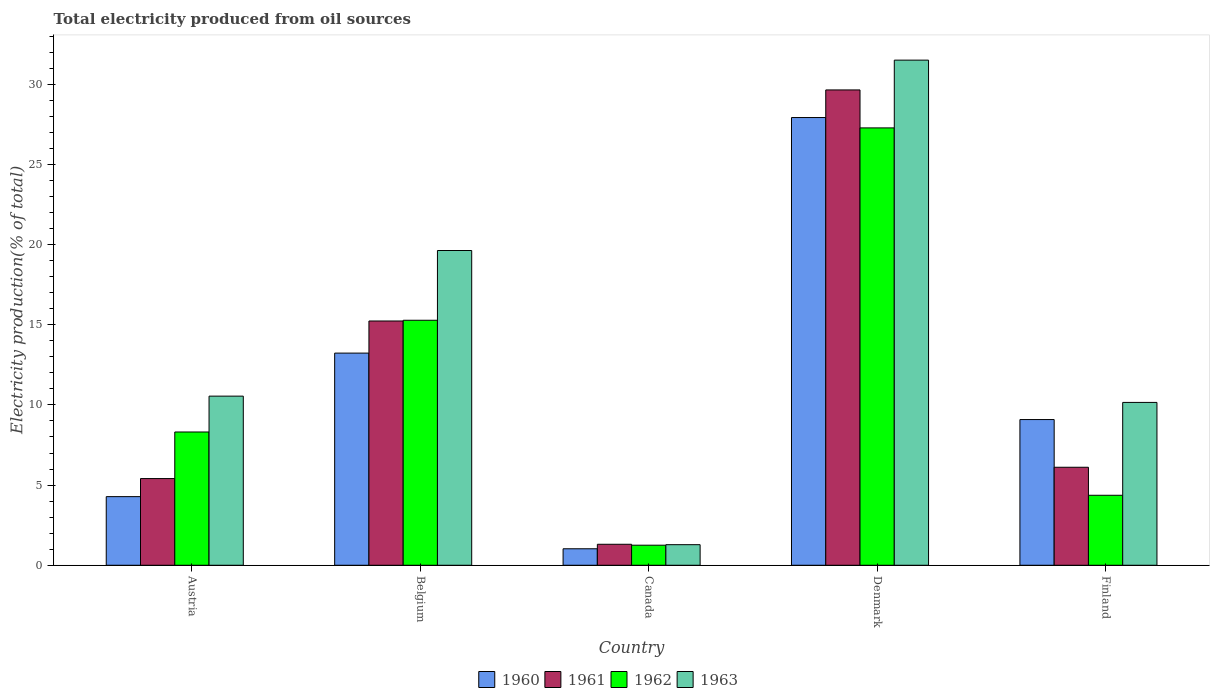How many groups of bars are there?
Offer a very short reply. 5. Are the number of bars per tick equal to the number of legend labels?
Ensure brevity in your answer.  Yes. How many bars are there on the 4th tick from the right?
Your answer should be compact. 4. What is the label of the 4th group of bars from the left?
Ensure brevity in your answer.  Denmark. In how many cases, is the number of bars for a given country not equal to the number of legend labels?
Your response must be concise. 0. What is the total electricity produced in 1963 in Denmark?
Your answer should be very brief. 31.51. Across all countries, what is the maximum total electricity produced in 1960?
Your answer should be compact. 27.92. Across all countries, what is the minimum total electricity produced in 1962?
Offer a terse response. 1.25. In which country was the total electricity produced in 1962 minimum?
Offer a terse response. Canada. What is the total total electricity produced in 1961 in the graph?
Provide a succinct answer. 57.71. What is the difference between the total electricity produced in 1960 in Canada and that in Finland?
Your response must be concise. -8.06. What is the difference between the total electricity produced in 1962 in Austria and the total electricity produced in 1960 in Canada?
Your answer should be compact. 7.28. What is the average total electricity produced in 1962 per country?
Keep it short and to the point. 11.3. What is the difference between the total electricity produced of/in 1962 and total electricity produced of/in 1960 in Canada?
Provide a short and direct response. 0.22. In how many countries, is the total electricity produced in 1962 greater than 16 %?
Make the answer very short. 1. What is the ratio of the total electricity produced in 1962 in Austria to that in Denmark?
Provide a succinct answer. 0.3. Is the total electricity produced in 1961 in Belgium less than that in Canada?
Ensure brevity in your answer.  No. Is the difference between the total electricity produced in 1962 in Austria and Denmark greater than the difference between the total electricity produced in 1960 in Austria and Denmark?
Offer a terse response. Yes. What is the difference between the highest and the second highest total electricity produced in 1961?
Your response must be concise. 23.53. What is the difference between the highest and the lowest total electricity produced in 1963?
Provide a short and direct response. 30.22. Is the sum of the total electricity produced in 1960 in Canada and Denmark greater than the maximum total electricity produced in 1962 across all countries?
Offer a terse response. Yes. What does the 1st bar from the right in Belgium represents?
Offer a terse response. 1963. Is it the case that in every country, the sum of the total electricity produced in 1960 and total electricity produced in 1961 is greater than the total electricity produced in 1963?
Give a very brief answer. No. Are all the bars in the graph horizontal?
Give a very brief answer. No. What is the difference between two consecutive major ticks on the Y-axis?
Ensure brevity in your answer.  5. Are the values on the major ticks of Y-axis written in scientific E-notation?
Provide a succinct answer. No. Does the graph contain any zero values?
Ensure brevity in your answer.  No. Does the graph contain grids?
Your response must be concise. No. How many legend labels are there?
Give a very brief answer. 4. What is the title of the graph?
Your response must be concise. Total electricity produced from oil sources. Does "1986" appear as one of the legend labels in the graph?
Offer a very short reply. No. What is the label or title of the X-axis?
Give a very brief answer. Country. What is the Electricity production(% of total) in 1960 in Austria?
Your response must be concise. 4.28. What is the Electricity production(% of total) in 1961 in Austria?
Ensure brevity in your answer.  5.41. What is the Electricity production(% of total) in 1962 in Austria?
Make the answer very short. 8.31. What is the Electricity production(% of total) in 1963 in Austria?
Offer a terse response. 10.55. What is the Electricity production(% of total) of 1960 in Belgium?
Ensure brevity in your answer.  13.23. What is the Electricity production(% of total) in 1961 in Belgium?
Your response must be concise. 15.23. What is the Electricity production(% of total) of 1962 in Belgium?
Offer a very short reply. 15.28. What is the Electricity production(% of total) of 1963 in Belgium?
Give a very brief answer. 19.63. What is the Electricity production(% of total) of 1960 in Canada?
Provide a succinct answer. 1.03. What is the Electricity production(% of total) in 1961 in Canada?
Keep it short and to the point. 1.31. What is the Electricity production(% of total) of 1962 in Canada?
Keep it short and to the point. 1.25. What is the Electricity production(% of total) of 1963 in Canada?
Make the answer very short. 1.28. What is the Electricity production(% of total) in 1960 in Denmark?
Make the answer very short. 27.92. What is the Electricity production(% of total) of 1961 in Denmark?
Provide a succinct answer. 29.65. What is the Electricity production(% of total) of 1962 in Denmark?
Your response must be concise. 27.28. What is the Electricity production(% of total) of 1963 in Denmark?
Your response must be concise. 31.51. What is the Electricity production(% of total) in 1960 in Finland?
Ensure brevity in your answer.  9.09. What is the Electricity production(% of total) in 1961 in Finland?
Offer a very short reply. 6.11. What is the Electricity production(% of total) in 1962 in Finland?
Make the answer very short. 4.36. What is the Electricity production(% of total) of 1963 in Finland?
Offer a very short reply. 10.16. Across all countries, what is the maximum Electricity production(% of total) in 1960?
Your response must be concise. 27.92. Across all countries, what is the maximum Electricity production(% of total) of 1961?
Your answer should be very brief. 29.65. Across all countries, what is the maximum Electricity production(% of total) in 1962?
Provide a succinct answer. 27.28. Across all countries, what is the maximum Electricity production(% of total) of 1963?
Ensure brevity in your answer.  31.51. Across all countries, what is the minimum Electricity production(% of total) in 1960?
Provide a succinct answer. 1.03. Across all countries, what is the minimum Electricity production(% of total) in 1961?
Give a very brief answer. 1.31. Across all countries, what is the minimum Electricity production(% of total) of 1962?
Offer a very short reply. 1.25. Across all countries, what is the minimum Electricity production(% of total) of 1963?
Provide a short and direct response. 1.28. What is the total Electricity production(% of total) in 1960 in the graph?
Offer a terse response. 55.55. What is the total Electricity production(% of total) in 1961 in the graph?
Offer a terse response. 57.71. What is the total Electricity production(% of total) of 1962 in the graph?
Provide a succinct answer. 56.49. What is the total Electricity production(% of total) of 1963 in the graph?
Your response must be concise. 73.12. What is the difference between the Electricity production(% of total) of 1960 in Austria and that in Belgium?
Keep it short and to the point. -8.95. What is the difference between the Electricity production(% of total) in 1961 in Austria and that in Belgium?
Your answer should be compact. -9.83. What is the difference between the Electricity production(% of total) in 1962 in Austria and that in Belgium?
Your response must be concise. -6.97. What is the difference between the Electricity production(% of total) in 1963 in Austria and that in Belgium?
Offer a terse response. -9.08. What is the difference between the Electricity production(% of total) in 1960 in Austria and that in Canada?
Provide a succinct answer. 3.25. What is the difference between the Electricity production(% of total) in 1961 in Austria and that in Canada?
Provide a succinct answer. 4.1. What is the difference between the Electricity production(% of total) in 1962 in Austria and that in Canada?
Your answer should be compact. 7.06. What is the difference between the Electricity production(% of total) in 1963 in Austria and that in Canada?
Offer a very short reply. 9.26. What is the difference between the Electricity production(% of total) in 1960 in Austria and that in Denmark?
Offer a terse response. -23.64. What is the difference between the Electricity production(% of total) in 1961 in Austria and that in Denmark?
Your answer should be compact. -24.24. What is the difference between the Electricity production(% of total) of 1962 in Austria and that in Denmark?
Keep it short and to the point. -18.97. What is the difference between the Electricity production(% of total) of 1963 in Austria and that in Denmark?
Provide a succinct answer. -20.96. What is the difference between the Electricity production(% of total) of 1960 in Austria and that in Finland?
Make the answer very short. -4.81. What is the difference between the Electricity production(% of total) of 1961 in Austria and that in Finland?
Your answer should be compact. -0.71. What is the difference between the Electricity production(% of total) of 1962 in Austria and that in Finland?
Offer a very short reply. 3.95. What is the difference between the Electricity production(% of total) in 1963 in Austria and that in Finland?
Your answer should be compact. 0.39. What is the difference between the Electricity production(% of total) in 1960 in Belgium and that in Canada?
Provide a short and direct response. 12.2. What is the difference between the Electricity production(% of total) of 1961 in Belgium and that in Canada?
Your response must be concise. 13.93. What is the difference between the Electricity production(% of total) in 1962 in Belgium and that in Canada?
Ensure brevity in your answer.  14.03. What is the difference between the Electricity production(% of total) in 1963 in Belgium and that in Canada?
Keep it short and to the point. 18.35. What is the difference between the Electricity production(% of total) in 1960 in Belgium and that in Denmark?
Offer a terse response. -14.69. What is the difference between the Electricity production(% of total) of 1961 in Belgium and that in Denmark?
Keep it short and to the point. -14.41. What is the difference between the Electricity production(% of total) of 1962 in Belgium and that in Denmark?
Ensure brevity in your answer.  -12. What is the difference between the Electricity production(% of total) in 1963 in Belgium and that in Denmark?
Offer a terse response. -11.87. What is the difference between the Electricity production(% of total) in 1960 in Belgium and that in Finland?
Offer a very short reply. 4.14. What is the difference between the Electricity production(% of total) of 1961 in Belgium and that in Finland?
Ensure brevity in your answer.  9.12. What is the difference between the Electricity production(% of total) of 1962 in Belgium and that in Finland?
Give a very brief answer. 10.92. What is the difference between the Electricity production(% of total) in 1963 in Belgium and that in Finland?
Your answer should be very brief. 9.47. What is the difference between the Electricity production(% of total) of 1960 in Canada and that in Denmark?
Ensure brevity in your answer.  -26.9. What is the difference between the Electricity production(% of total) in 1961 in Canada and that in Denmark?
Your response must be concise. -28.34. What is the difference between the Electricity production(% of total) of 1962 in Canada and that in Denmark?
Keep it short and to the point. -26.03. What is the difference between the Electricity production(% of total) of 1963 in Canada and that in Denmark?
Your answer should be very brief. -30.22. What is the difference between the Electricity production(% of total) in 1960 in Canada and that in Finland?
Keep it short and to the point. -8.06. What is the difference between the Electricity production(% of total) in 1961 in Canada and that in Finland?
Keep it short and to the point. -4.8. What is the difference between the Electricity production(% of total) in 1962 in Canada and that in Finland?
Your response must be concise. -3.11. What is the difference between the Electricity production(% of total) in 1963 in Canada and that in Finland?
Your response must be concise. -8.87. What is the difference between the Electricity production(% of total) in 1960 in Denmark and that in Finland?
Your answer should be very brief. 18.84. What is the difference between the Electricity production(% of total) in 1961 in Denmark and that in Finland?
Ensure brevity in your answer.  23.53. What is the difference between the Electricity production(% of total) of 1962 in Denmark and that in Finland?
Make the answer very short. 22.91. What is the difference between the Electricity production(% of total) of 1963 in Denmark and that in Finland?
Your response must be concise. 21.35. What is the difference between the Electricity production(% of total) in 1960 in Austria and the Electricity production(% of total) in 1961 in Belgium?
Offer a terse response. -10.95. What is the difference between the Electricity production(% of total) in 1960 in Austria and the Electricity production(% of total) in 1962 in Belgium?
Offer a very short reply. -11. What is the difference between the Electricity production(% of total) in 1960 in Austria and the Electricity production(% of total) in 1963 in Belgium?
Give a very brief answer. -15.35. What is the difference between the Electricity production(% of total) in 1961 in Austria and the Electricity production(% of total) in 1962 in Belgium?
Your response must be concise. -9.87. What is the difference between the Electricity production(% of total) in 1961 in Austria and the Electricity production(% of total) in 1963 in Belgium?
Your response must be concise. -14.22. What is the difference between the Electricity production(% of total) in 1962 in Austria and the Electricity production(% of total) in 1963 in Belgium?
Ensure brevity in your answer.  -11.32. What is the difference between the Electricity production(% of total) of 1960 in Austria and the Electricity production(% of total) of 1961 in Canada?
Offer a terse response. 2.97. What is the difference between the Electricity production(% of total) in 1960 in Austria and the Electricity production(% of total) in 1962 in Canada?
Ensure brevity in your answer.  3.03. What is the difference between the Electricity production(% of total) of 1960 in Austria and the Electricity production(% of total) of 1963 in Canada?
Provide a succinct answer. 3. What is the difference between the Electricity production(% of total) in 1961 in Austria and the Electricity production(% of total) in 1962 in Canada?
Keep it short and to the point. 4.16. What is the difference between the Electricity production(% of total) of 1961 in Austria and the Electricity production(% of total) of 1963 in Canada?
Your answer should be very brief. 4.12. What is the difference between the Electricity production(% of total) in 1962 in Austria and the Electricity production(% of total) in 1963 in Canada?
Keep it short and to the point. 7.03. What is the difference between the Electricity production(% of total) of 1960 in Austria and the Electricity production(% of total) of 1961 in Denmark?
Make the answer very short. -25.37. What is the difference between the Electricity production(% of total) of 1960 in Austria and the Electricity production(% of total) of 1962 in Denmark?
Ensure brevity in your answer.  -23. What is the difference between the Electricity production(% of total) of 1960 in Austria and the Electricity production(% of total) of 1963 in Denmark?
Provide a succinct answer. -27.22. What is the difference between the Electricity production(% of total) of 1961 in Austria and the Electricity production(% of total) of 1962 in Denmark?
Provide a succinct answer. -21.87. What is the difference between the Electricity production(% of total) of 1961 in Austria and the Electricity production(% of total) of 1963 in Denmark?
Make the answer very short. -26.1. What is the difference between the Electricity production(% of total) in 1962 in Austria and the Electricity production(% of total) in 1963 in Denmark?
Provide a succinct answer. -23.19. What is the difference between the Electricity production(% of total) of 1960 in Austria and the Electricity production(% of total) of 1961 in Finland?
Provide a succinct answer. -1.83. What is the difference between the Electricity production(% of total) in 1960 in Austria and the Electricity production(% of total) in 1962 in Finland?
Make the answer very short. -0.08. What is the difference between the Electricity production(% of total) of 1960 in Austria and the Electricity production(% of total) of 1963 in Finland?
Provide a short and direct response. -5.88. What is the difference between the Electricity production(% of total) of 1961 in Austria and the Electricity production(% of total) of 1962 in Finland?
Offer a terse response. 1.04. What is the difference between the Electricity production(% of total) in 1961 in Austria and the Electricity production(% of total) in 1963 in Finland?
Provide a short and direct response. -4.75. What is the difference between the Electricity production(% of total) of 1962 in Austria and the Electricity production(% of total) of 1963 in Finland?
Provide a succinct answer. -1.84. What is the difference between the Electricity production(% of total) of 1960 in Belgium and the Electricity production(% of total) of 1961 in Canada?
Provide a succinct answer. 11.92. What is the difference between the Electricity production(% of total) of 1960 in Belgium and the Electricity production(% of total) of 1962 in Canada?
Offer a very short reply. 11.98. What is the difference between the Electricity production(% of total) in 1960 in Belgium and the Electricity production(% of total) in 1963 in Canada?
Provide a succinct answer. 11.95. What is the difference between the Electricity production(% of total) of 1961 in Belgium and the Electricity production(% of total) of 1962 in Canada?
Keep it short and to the point. 13.98. What is the difference between the Electricity production(% of total) in 1961 in Belgium and the Electricity production(% of total) in 1963 in Canada?
Give a very brief answer. 13.95. What is the difference between the Electricity production(% of total) of 1962 in Belgium and the Electricity production(% of total) of 1963 in Canada?
Make the answer very short. 14. What is the difference between the Electricity production(% of total) of 1960 in Belgium and the Electricity production(% of total) of 1961 in Denmark?
Give a very brief answer. -16.41. What is the difference between the Electricity production(% of total) in 1960 in Belgium and the Electricity production(% of total) in 1962 in Denmark?
Provide a succinct answer. -14.05. What is the difference between the Electricity production(% of total) in 1960 in Belgium and the Electricity production(% of total) in 1963 in Denmark?
Make the answer very short. -18.27. What is the difference between the Electricity production(% of total) in 1961 in Belgium and the Electricity production(% of total) in 1962 in Denmark?
Provide a short and direct response. -12.04. What is the difference between the Electricity production(% of total) in 1961 in Belgium and the Electricity production(% of total) in 1963 in Denmark?
Give a very brief answer. -16.27. What is the difference between the Electricity production(% of total) in 1962 in Belgium and the Electricity production(% of total) in 1963 in Denmark?
Your response must be concise. -16.22. What is the difference between the Electricity production(% of total) of 1960 in Belgium and the Electricity production(% of total) of 1961 in Finland?
Your answer should be compact. 7.12. What is the difference between the Electricity production(% of total) in 1960 in Belgium and the Electricity production(% of total) in 1962 in Finland?
Your response must be concise. 8.87. What is the difference between the Electricity production(% of total) in 1960 in Belgium and the Electricity production(% of total) in 1963 in Finland?
Your answer should be compact. 3.08. What is the difference between the Electricity production(% of total) of 1961 in Belgium and the Electricity production(% of total) of 1962 in Finland?
Provide a succinct answer. 10.87. What is the difference between the Electricity production(% of total) of 1961 in Belgium and the Electricity production(% of total) of 1963 in Finland?
Provide a succinct answer. 5.08. What is the difference between the Electricity production(% of total) of 1962 in Belgium and the Electricity production(% of total) of 1963 in Finland?
Give a very brief answer. 5.12. What is the difference between the Electricity production(% of total) of 1960 in Canada and the Electricity production(% of total) of 1961 in Denmark?
Provide a succinct answer. -28.62. What is the difference between the Electricity production(% of total) of 1960 in Canada and the Electricity production(% of total) of 1962 in Denmark?
Provide a succinct answer. -26.25. What is the difference between the Electricity production(% of total) in 1960 in Canada and the Electricity production(% of total) in 1963 in Denmark?
Your answer should be compact. -30.48. What is the difference between the Electricity production(% of total) in 1961 in Canada and the Electricity production(% of total) in 1962 in Denmark?
Keep it short and to the point. -25.97. What is the difference between the Electricity production(% of total) in 1961 in Canada and the Electricity production(% of total) in 1963 in Denmark?
Offer a terse response. -30.2. What is the difference between the Electricity production(% of total) in 1962 in Canada and the Electricity production(% of total) in 1963 in Denmark?
Offer a terse response. -30.25. What is the difference between the Electricity production(% of total) of 1960 in Canada and the Electricity production(% of total) of 1961 in Finland?
Offer a terse response. -5.08. What is the difference between the Electricity production(% of total) in 1960 in Canada and the Electricity production(% of total) in 1962 in Finland?
Your answer should be compact. -3.34. What is the difference between the Electricity production(% of total) of 1960 in Canada and the Electricity production(% of total) of 1963 in Finland?
Make the answer very short. -9.13. What is the difference between the Electricity production(% of total) in 1961 in Canada and the Electricity production(% of total) in 1962 in Finland?
Provide a short and direct response. -3.06. What is the difference between the Electricity production(% of total) in 1961 in Canada and the Electricity production(% of total) in 1963 in Finland?
Make the answer very short. -8.85. What is the difference between the Electricity production(% of total) of 1962 in Canada and the Electricity production(% of total) of 1963 in Finland?
Provide a succinct answer. -8.91. What is the difference between the Electricity production(% of total) of 1960 in Denmark and the Electricity production(% of total) of 1961 in Finland?
Your answer should be very brief. 21.81. What is the difference between the Electricity production(% of total) in 1960 in Denmark and the Electricity production(% of total) in 1962 in Finland?
Provide a short and direct response. 23.56. What is the difference between the Electricity production(% of total) in 1960 in Denmark and the Electricity production(% of total) in 1963 in Finland?
Your answer should be compact. 17.77. What is the difference between the Electricity production(% of total) of 1961 in Denmark and the Electricity production(% of total) of 1962 in Finland?
Your answer should be very brief. 25.28. What is the difference between the Electricity production(% of total) in 1961 in Denmark and the Electricity production(% of total) in 1963 in Finland?
Make the answer very short. 19.49. What is the difference between the Electricity production(% of total) of 1962 in Denmark and the Electricity production(% of total) of 1963 in Finland?
Offer a terse response. 17.12. What is the average Electricity production(% of total) in 1960 per country?
Your answer should be compact. 11.11. What is the average Electricity production(% of total) of 1961 per country?
Make the answer very short. 11.54. What is the average Electricity production(% of total) in 1962 per country?
Ensure brevity in your answer.  11.3. What is the average Electricity production(% of total) in 1963 per country?
Provide a short and direct response. 14.62. What is the difference between the Electricity production(% of total) of 1960 and Electricity production(% of total) of 1961 in Austria?
Your answer should be compact. -1.13. What is the difference between the Electricity production(% of total) of 1960 and Electricity production(% of total) of 1962 in Austria?
Provide a succinct answer. -4.03. What is the difference between the Electricity production(% of total) in 1960 and Electricity production(% of total) in 1963 in Austria?
Give a very brief answer. -6.27. What is the difference between the Electricity production(% of total) of 1961 and Electricity production(% of total) of 1962 in Austria?
Provide a short and direct response. -2.91. What is the difference between the Electricity production(% of total) in 1961 and Electricity production(% of total) in 1963 in Austria?
Your response must be concise. -5.14. What is the difference between the Electricity production(% of total) in 1962 and Electricity production(% of total) in 1963 in Austria?
Offer a very short reply. -2.24. What is the difference between the Electricity production(% of total) in 1960 and Electricity production(% of total) in 1961 in Belgium?
Ensure brevity in your answer.  -2. What is the difference between the Electricity production(% of total) of 1960 and Electricity production(% of total) of 1962 in Belgium?
Offer a terse response. -2.05. What is the difference between the Electricity production(% of total) of 1960 and Electricity production(% of total) of 1963 in Belgium?
Keep it short and to the point. -6.4. What is the difference between the Electricity production(% of total) of 1961 and Electricity production(% of total) of 1962 in Belgium?
Offer a very short reply. -0.05. What is the difference between the Electricity production(% of total) in 1961 and Electricity production(% of total) in 1963 in Belgium?
Offer a very short reply. -4.4. What is the difference between the Electricity production(% of total) in 1962 and Electricity production(% of total) in 1963 in Belgium?
Keep it short and to the point. -4.35. What is the difference between the Electricity production(% of total) of 1960 and Electricity production(% of total) of 1961 in Canada?
Your response must be concise. -0.28. What is the difference between the Electricity production(% of total) in 1960 and Electricity production(% of total) in 1962 in Canada?
Provide a succinct answer. -0.22. What is the difference between the Electricity production(% of total) in 1960 and Electricity production(% of total) in 1963 in Canada?
Your answer should be very brief. -0.26. What is the difference between the Electricity production(% of total) in 1961 and Electricity production(% of total) in 1962 in Canada?
Offer a very short reply. 0.06. What is the difference between the Electricity production(% of total) of 1961 and Electricity production(% of total) of 1963 in Canada?
Ensure brevity in your answer.  0.03. What is the difference between the Electricity production(% of total) in 1962 and Electricity production(% of total) in 1963 in Canada?
Your answer should be compact. -0.03. What is the difference between the Electricity production(% of total) of 1960 and Electricity production(% of total) of 1961 in Denmark?
Make the answer very short. -1.72. What is the difference between the Electricity production(% of total) in 1960 and Electricity production(% of total) in 1962 in Denmark?
Your response must be concise. 0.65. What is the difference between the Electricity production(% of total) of 1960 and Electricity production(% of total) of 1963 in Denmark?
Give a very brief answer. -3.58. What is the difference between the Electricity production(% of total) in 1961 and Electricity production(% of total) in 1962 in Denmark?
Your response must be concise. 2.37. What is the difference between the Electricity production(% of total) of 1961 and Electricity production(% of total) of 1963 in Denmark?
Your answer should be very brief. -1.86. What is the difference between the Electricity production(% of total) in 1962 and Electricity production(% of total) in 1963 in Denmark?
Keep it short and to the point. -4.23. What is the difference between the Electricity production(% of total) of 1960 and Electricity production(% of total) of 1961 in Finland?
Ensure brevity in your answer.  2.98. What is the difference between the Electricity production(% of total) of 1960 and Electricity production(% of total) of 1962 in Finland?
Provide a short and direct response. 4.72. What is the difference between the Electricity production(% of total) in 1960 and Electricity production(% of total) in 1963 in Finland?
Provide a short and direct response. -1.07. What is the difference between the Electricity production(% of total) in 1961 and Electricity production(% of total) in 1962 in Finland?
Provide a succinct answer. 1.75. What is the difference between the Electricity production(% of total) of 1961 and Electricity production(% of total) of 1963 in Finland?
Your answer should be very brief. -4.04. What is the difference between the Electricity production(% of total) of 1962 and Electricity production(% of total) of 1963 in Finland?
Your answer should be compact. -5.79. What is the ratio of the Electricity production(% of total) of 1960 in Austria to that in Belgium?
Give a very brief answer. 0.32. What is the ratio of the Electricity production(% of total) of 1961 in Austria to that in Belgium?
Your answer should be very brief. 0.35. What is the ratio of the Electricity production(% of total) of 1962 in Austria to that in Belgium?
Your answer should be very brief. 0.54. What is the ratio of the Electricity production(% of total) in 1963 in Austria to that in Belgium?
Provide a succinct answer. 0.54. What is the ratio of the Electricity production(% of total) in 1960 in Austria to that in Canada?
Offer a terse response. 4.16. What is the ratio of the Electricity production(% of total) of 1961 in Austria to that in Canada?
Keep it short and to the point. 4.13. What is the ratio of the Electricity production(% of total) of 1962 in Austria to that in Canada?
Your response must be concise. 6.64. What is the ratio of the Electricity production(% of total) of 1963 in Austria to that in Canada?
Give a very brief answer. 8.22. What is the ratio of the Electricity production(% of total) of 1960 in Austria to that in Denmark?
Offer a terse response. 0.15. What is the ratio of the Electricity production(% of total) in 1961 in Austria to that in Denmark?
Give a very brief answer. 0.18. What is the ratio of the Electricity production(% of total) of 1962 in Austria to that in Denmark?
Your answer should be very brief. 0.3. What is the ratio of the Electricity production(% of total) in 1963 in Austria to that in Denmark?
Ensure brevity in your answer.  0.33. What is the ratio of the Electricity production(% of total) in 1960 in Austria to that in Finland?
Make the answer very short. 0.47. What is the ratio of the Electricity production(% of total) of 1961 in Austria to that in Finland?
Provide a succinct answer. 0.88. What is the ratio of the Electricity production(% of total) in 1962 in Austria to that in Finland?
Your response must be concise. 1.9. What is the ratio of the Electricity production(% of total) of 1963 in Austria to that in Finland?
Offer a terse response. 1.04. What is the ratio of the Electricity production(% of total) of 1960 in Belgium to that in Canada?
Offer a very short reply. 12.86. What is the ratio of the Electricity production(% of total) of 1961 in Belgium to that in Canada?
Ensure brevity in your answer.  11.64. What is the ratio of the Electricity production(% of total) of 1962 in Belgium to that in Canada?
Offer a terse response. 12.21. What is the ratio of the Electricity production(% of total) in 1963 in Belgium to that in Canada?
Ensure brevity in your answer.  15.29. What is the ratio of the Electricity production(% of total) in 1960 in Belgium to that in Denmark?
Offer a very short reply. 0.47. What is the ratio of the Electricity production(% of total) in 1961 in Belgium to that in Denmark?
Provide a short and direct response. 0.51. What is the ratio of the Electricity production(% of total) in 1962 in Belgium to that in Denmark?
Keep it short and to the point. 0.56. What is the ratio of the Electricity production(% of total) in 1963 in Belgium to that in Denmark?
Make the answer very short. 0.62. What is the ratio of the Electricity production(% of total) in 1960 in Belgium to that in Finland?
Make the answer very short. 1.46. What is the ratio of the Electricity production(% of total) in 1961 in Belgium to that in Finland?
Provide a succinct answer. 2.49. What is the ratio of the Electricity production(% of total) of 1962 in Belgium to that in Finland?
Ensure brevity in your answer.  3.5. What is the ratio of the Electricity production(% of total) of 1963 in Belgium to that in Finland?
Give a very brief answer. 1.93. What is the ratio of the Electricity production(% of total) of 1960 in Canada to that in Denmark?
Keep it short and to the point. 0.04. What is the ratio of the Electricity production(% of total) of 1961 in Canada to that in Denmark?
Your answer should be very brief. 0.04. What is the ratio of the Electricity production(% of total) in 1962 in Canada to that in Denmark?
Make the answer very short. 0.05. What is the ratio of the Electricity production(% of total) of 1963 in Canada to that in Denmark?
Offer a terse response. 0.04. What is the ratio of the Electricity production(% of total) of 1960 in Canada to that in Finland?
Offer a very short reply. 0.11. What is the ratio of the Electricity production(% of total) in 1961 in Canada to that in Finland?
Offer a very short reply. 0.21. What is the ratio of the Electricity production(% of total) in 1962 in Canada to that in Finland?
Provide a succinct answer. 0.29. What is the ratio of the Electricity production(% of total) of 1963 in Canada to that in Finland?
Your answer should be very brief. 0.13. What is the ratio of the Electricity production(% of total) of 1960 in Denmark to that in Finland?
Your response must be concise. 3.07. What is the ratio of the Electricity production(% of total) of 1961 in Denmark to that in Finland?
Keep it short and to the point. 4.85. What is the ratio of the Electricity production(% of total) of 1962 in Denmark to that in Finland?
Your answer should be compact. 6.25. What is the ratio of the Electricity production(% of total) of 1963 in Denmark to that in Finland?
Offer a terse response. 3.1. What is the difference between the highest and the second highest Electricity production(% of total) of 1960?
Offer a very short reply. 14.69. What is the difference between the highest and the second highest Electricity production(% of total) of 1961?
Offer a terse response. 14.41. What is the difference between the highest and the second highest Electricity production(% of total) in 1962?
Your answer should be compact. 12. What is the difference between the highest and the second highest Electricity production(% of total) of 1963?
Give a very brief answer. 11.87. What is the difference between the highest and the lowest Electricity production(% of total) of 1960?
Make the answer very short. 26.9. What is the difference between the highest and the lowest Electricity production(% of total) of 1961?
Your answer should be very brief. 28.34. What is the difference between the highest and the lowest Electricity production(% of total) in 1962?
Provide a succinct answer. 26.03. What is the difference between the highest and the lowest Electricity production(% of total) of 1963?
Give a very brief answer. 30.22. 